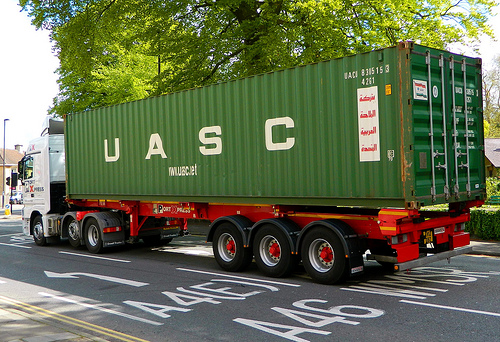Are there any white beds or cabinets in this image? No, there are no white beds or cabinets visible in this image. 